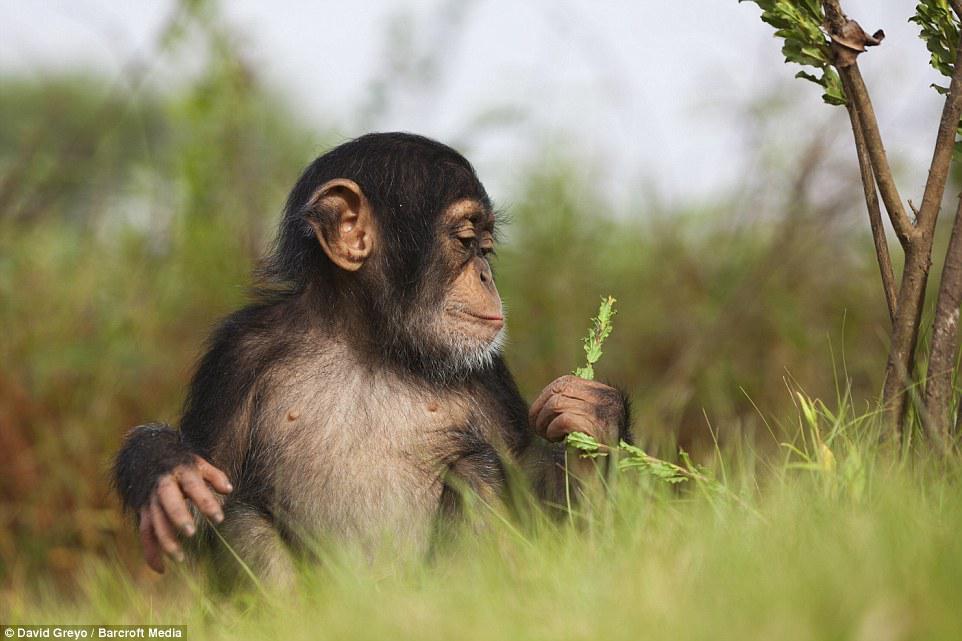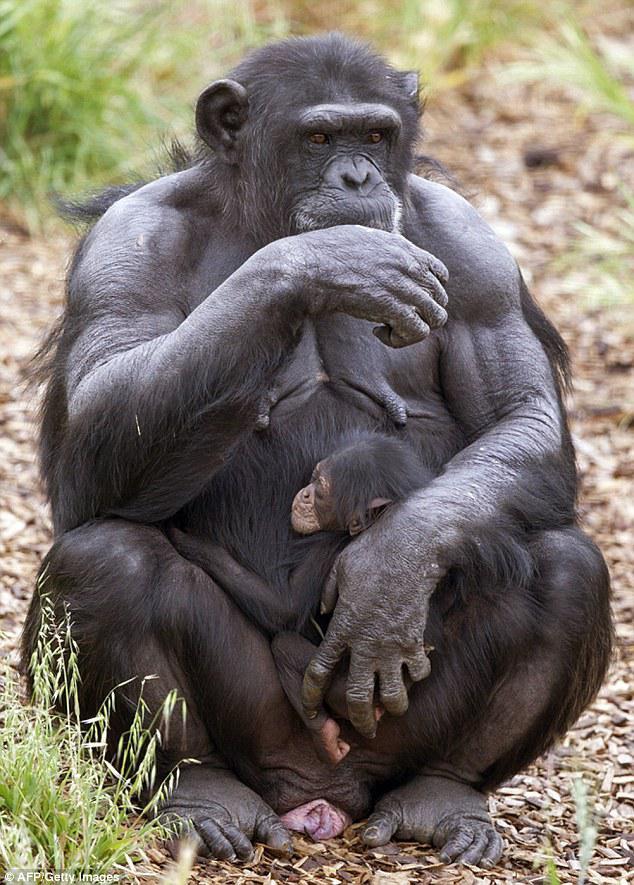The first image is the image on the left, the second image is the image on the right. Evaluate the accuracy of this statement regarding the images: "In one of the images, there is just one baby chimpanzee". Is it true? Answer yes or no. Yes. The first image is the image on the left, the second image is the image on the right. Analyze the images presented: Is the assertion "The right image shows an adult chimp sitting upright, with a baby held in front." valid? Answer yes or no. Yes. 